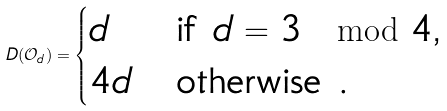<formula> <loc_0><loc_0><loc_500><loc_500>D ( \mathcal { O } _ { d } ) = \begin{cases} d & \text {if $d=3 \mod 4$,} \\ 4 d & \text {otherwise .} \end{cases}</formula> 